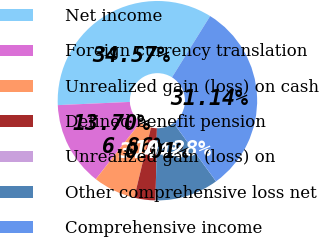Convert chart to OTSL. <chart><loc_0><loc_0><loc_500><loc_500><pie_chart><fcel>Net income<fcel>Foreign currency translation<fcel>Unrealized gain (loss) on cash<fcel>Defined benefit pension<fcel>Unrealized gain (loss) on<fcel>Other comprehensive loss net<fcel>Comprehensive income<nl><fcel>34.57%<fcel>13.7%<fcel>6.86%<fcel>3.44%<fcel>0.01%<fcel>10.28%<fcel>31.14%<nl></chart> 